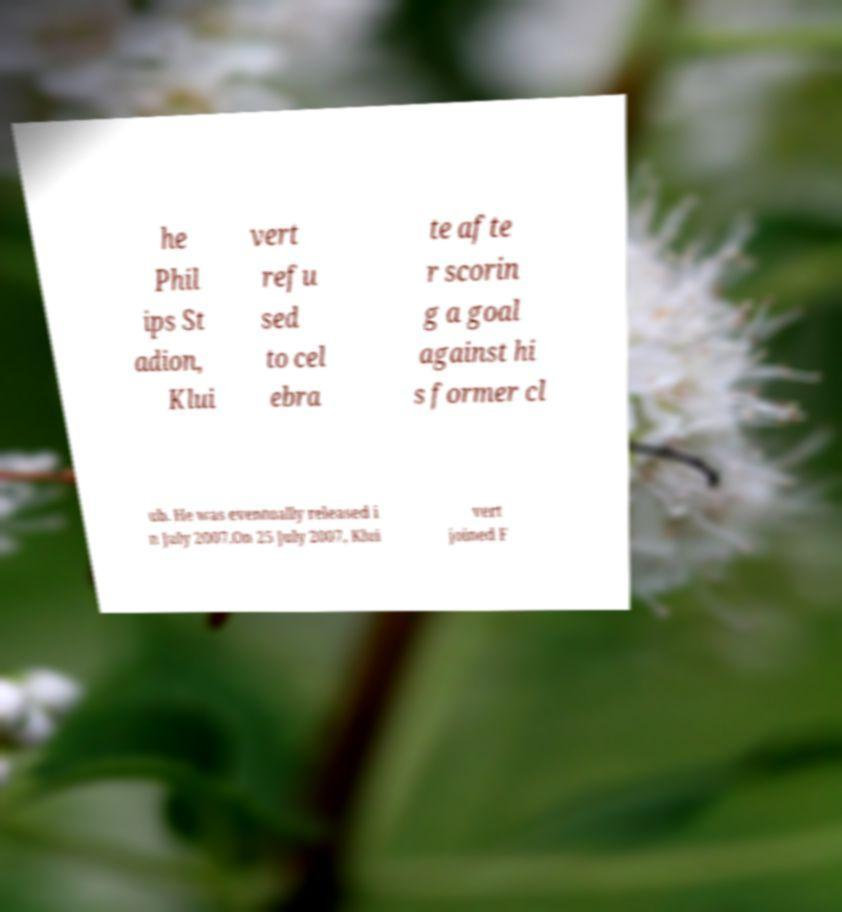Please identify and transcribe the text found in this image. he Phil ips St adion, Klui vert refu sed to cel ebra te afte r scorin g a goal against hi s former cl ub. He was eventually released i n July 2007.On 25 July 2007, Klui vert joined F 